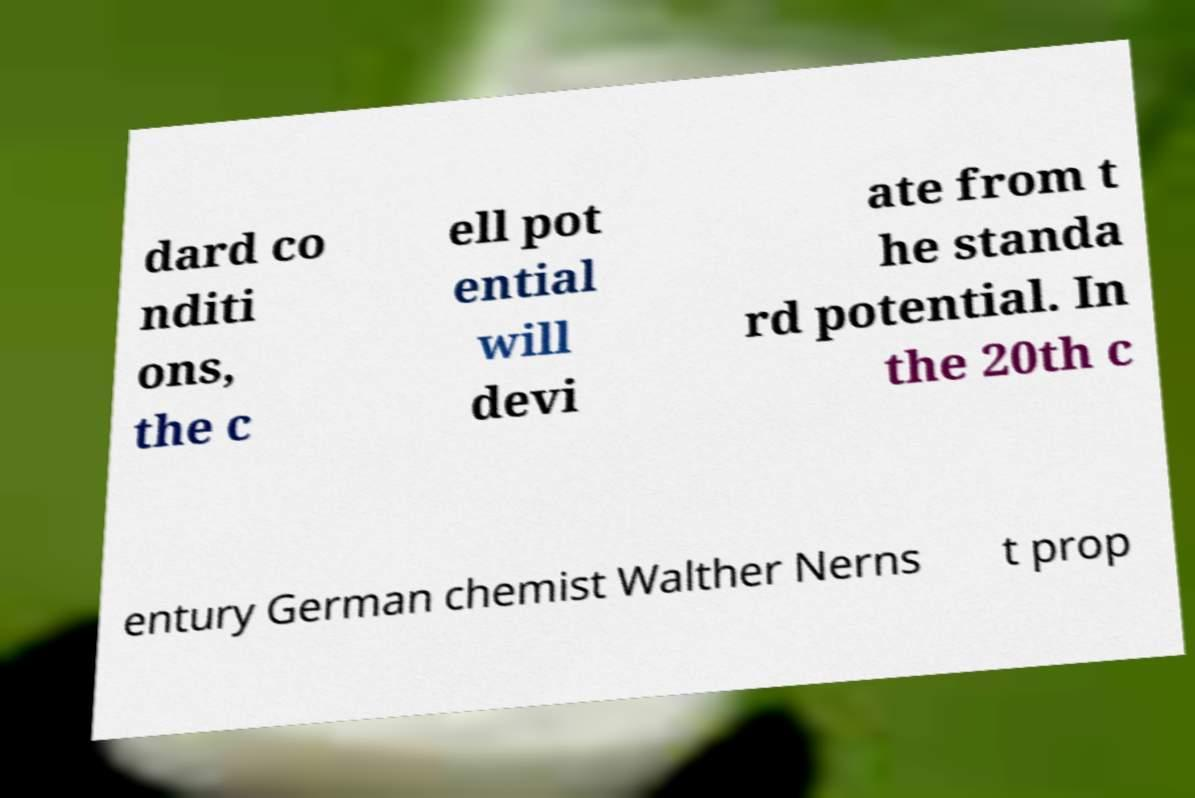Could you assist in decoding the text presented in this image and type it out clearly? dard co nditi ons, the c ell pot ential will devi ate from t he standa rd potential. In the 20th c entury German chemist Walther Nerns t prop 